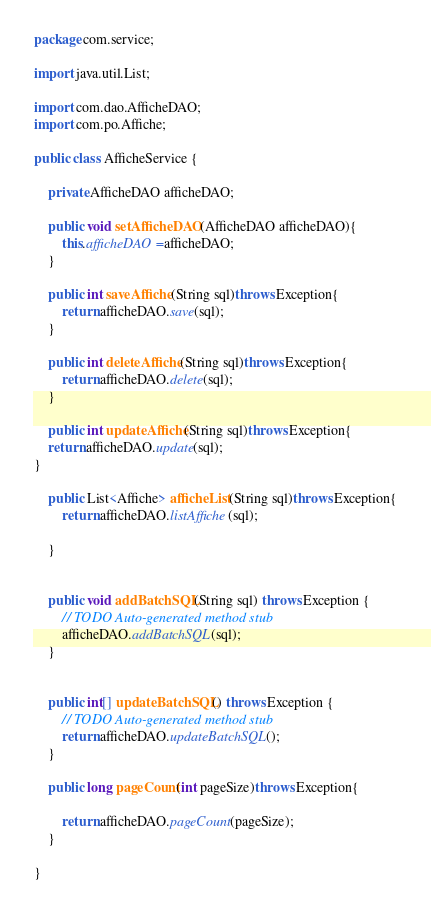Convert code to text. <code><loc_0><loc_0><loc_500><loc_500><_Java_>package com.service;

import java.util.List;

import com.dao.AfficheDAO;
import com.po.Affiche;

public class AfficheService {

	private AfficheDAO afficheDAO;
	
	public void setAfficheDAO(AfficheDAO afficheDAO){
		this.afficheDAO =afficheDAO;
	}

	public int saveAffiche(String sql)throws Exception{
		return afficheDAO.save(sql);
	}

	public int deleteAffiche(String sql)throws Exception{
		return afficheDAO.delete(sql);
	}

	public int updateAffiche(String sql)throws Exception{
	return afficheDAO.update(sql);
}
	
	public List<Affiche> afficheList(String sql)throws Exception{
		return afficheDAO.listAffiche(sql);
		
	}
	

	public void addBatchSQL(String sql) throws Exception {
		// TODO Auto-generated method stub
		afficheDAO.addBatchSQL(sql);
	}


	public int[] updateBatchSQL() throws Exception {
		// TODO Auto-generated method stub
		return afficheDAO.updateBatchSQL();
	}
	
	public long pageCount(int pageSize)throws Exception{
		
		return afficheDAO.pageCount(pageSize);
	}
	
}
</code> 